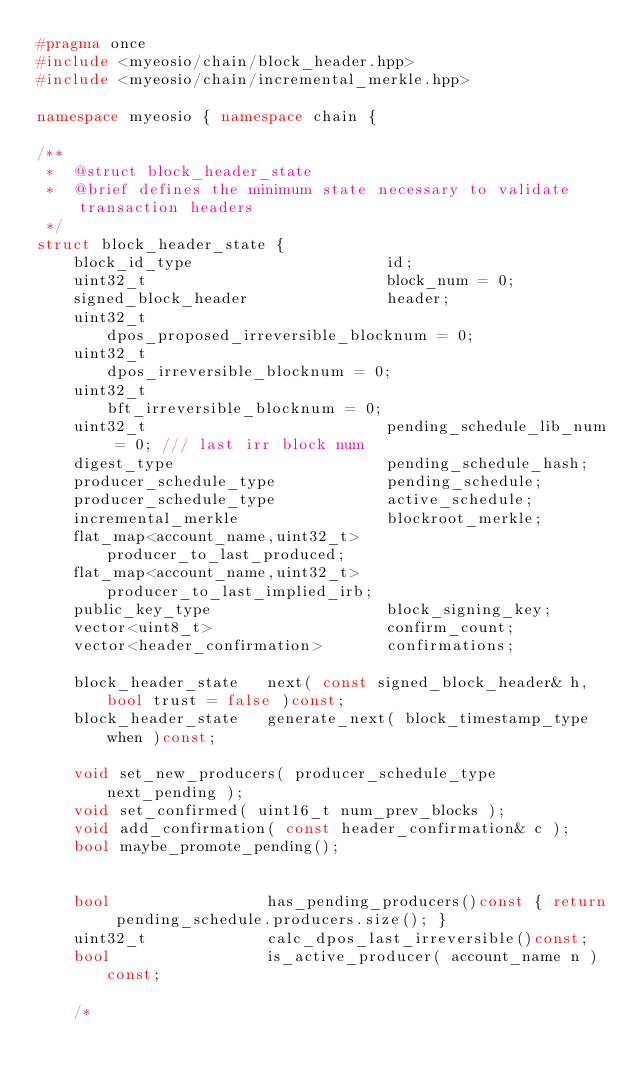Convert code to text. <code><loc_0><loc_0><loc_500><loc_500><_C++_>#pragma once
#include <myeosio/chain/block_header.hpp>
#include <myeosio/chain/incremental_merkle.hpp>

namespace myeosio { namespace chain {

/**
 *  @struct block_header_state
 *  @brief defines the minimum state necessary to validate transaction headers
 */
struct block_header_state {
    block_id_type                     id;
    uint32_t                          block_num = 0;
    signed_block_header               header;
    uint32_t                          dpos_proposed_irreversible_blocknum = 0;
    uint32_t                          dpos_irreversible_blocknum = 0;
    uint32_t                          bft_irreversible_blocknum = 0;
    uint32_t                          pending_schedule_lib_num = 0; /// last irr block num
    digest_type                       pending_schedule_hash;
    producer_schedule_type            pending_schedule;
    producer_schedule_type            active_schedule;
    incremental_merkle                blockroot_merkle;
    flat_map<account_name,uint32_t>   producer_to_last_produced;
    flat_map<account_name,uint32_t>   producer_to_last_implied_irb;
    public_key_type                   block_signing_key;
    vector<uint8_t>                   confirm_count;
    vector<header_confirmation>       confirmations;

    block_header_state   next( const signed_block_header& h, bool trust = false )const;
    block_header_state   generate_next( block_timestamp_type when )const;

    void set_new_producers( producer_schedule_type next_pending );
    void set_confirmed( uint16_t num_prev_blocks );
    void add_confirmation( const header_confirmation& c );
    bool maybe_promote_pending();


    bool                 has_pending_producers()const { return pending_schedule.producers.size(); }
    uint32_t             calc_dpos_last_irreversible()const;
    bool                 is_active_producer( account_name n )const;

    /*</code> 